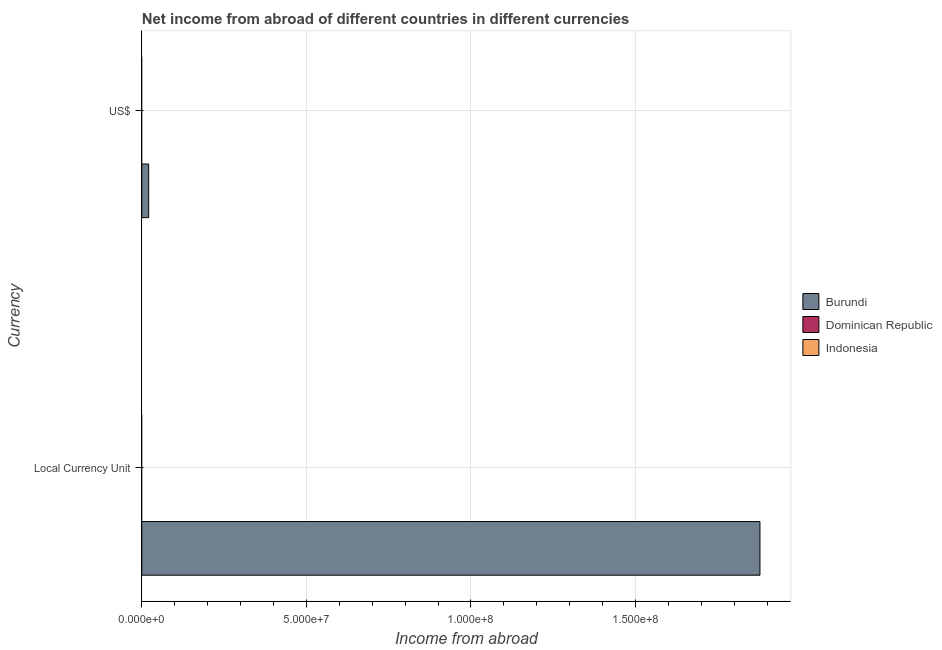How many bars are there on the 2nd tick from the top?
Make the answer very short. 1. How many bars are there on the 2nd tick from the bottom?
Your answer should be compact. 1. What is the label of the 2nd group of bars from the top?
Provide a succinct answer. Local Currency Unit. What is the income from abroad in us$ in Burundi?
Your response must be concise. 2.09e+06. Across all countries, what is the maximum income from abroad in constant 2005 us$?
Offer a very short reply. 1.88e+08. Across all countries, what is the minimum income from abroad in constant 2005 us$?
Make the answer very short. 0. In which country was the income from abroad in us$ maximum?
Give a very brief answer. Burundi. What is the total income from abroad in us$ in the graph?
Offer a very short reply. 2.09e+06. What is the difference between the income from abroad in constant 2005 us$ in Dominican Republic and the income from abroad in us$ in Indonesia?
Your answer should be compact. 0. What is the average income from abroad in us$ per country?
Give a very brief answer. 6.96e+05. What is the difference between the income from abroad in constant 2005 us$ and income from abroad in us$ in Burundi?
Provide a succinct answer. 1.86e+08. Are all the bars in the graph horizontal?
Give a very brief answer. Yes. Are the values on the major ticks of X-axis written in scientific E-notation?
Provide a succinct answer. Yes. Does the graph contain any zero values?
Make the answer very short. Yes. Does the graph contain grids?
Make the answer very short. Yes. Where does the legend appear in the graph?
Offer a very short reply. Center right. What is the title of the graph?
Provide a succinct answer. Net income from abroad of different countries in different currencies. Does "United States" appear as one of the legend labels in the graph?
Provide a succinct answer. No. What is the label or title of the X-axis?
Offer a very short reply. Income from abroad. What is the label or title of the Y-axis?
Ensure brevity in your answer.  Currency. What is the Income from abroad of Burundi in Local Currency Unit?
Your answer should be compact. 1.88e+08. What is the Income from abroad of Dominican Republic in Local Currency Unit?
Your answer should be compact. 0. What is the Income from abroad of Indonesia in Local Currency Unit?
Your response must be concise. 0. What is the Income from abroad of Burundi in US$?
Offer a terse response. 2.09e+06. What is the Income from abroad in Dominican Republic in US$?
Your answer should be compact. 0. What is the Income from abroad of Indonesia in US$?
Give a very brief answer. 0. Across all Currency, what is the maximum Income from abroad of Burundi?
Your answer should be very brief. 1.88e+08. Across all Currency, what is the minimum Income from abroad in Burundi?
Offer a very short reply. 2.09e+06. What is the total Income from abroad in Burundi in the graph?
Offer a terse response. 1.90e+08. What is the total Income from abroad of Dominican Republic in the graph?
Keep it short and to the point. 0. What is the total Income from abroad of Indonesia in the graph?
Your response must be concise. 0. What is the difference between the Income from abroad in Burundi in Local Currency Unit and that in US$?
Make the answer very short. 1.86e+08. What is the average Income from abroad in Burundi per Currency?
Keep it short and to the point. 9.49e+07. What is the average Income from abroad in Dominican Republic per Currency?
Provide a succinct answer. 0. What is the ratio of the Income from abroad in Burundi in Local Currency Unit to that in US$?
Offer a very short reply. 90. What is the difference between the highest and the second highest Income from abroad in Burundi?
Make the answer very short. 1.86e+08. What is the difference between the highest and the lowest Income from abroad in Burundi?
Your answer should be compact. 1.86e+08. 